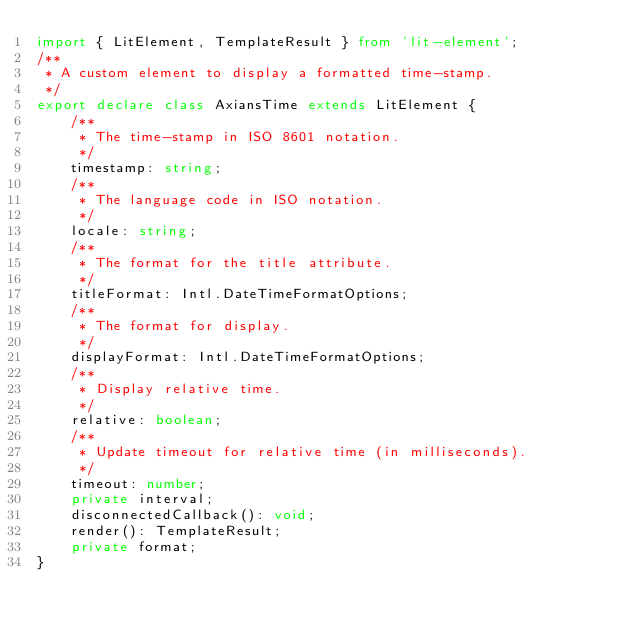Convert code to text. <code><loc_0><loc_0><loc_500><loc_500><_TypeScript_>import { LitElement, TemplateResult } from 'lit-element';
/**
 * A custom element to display a formatted time-stamp.
 */
export declare class AxiansTime extends LitElement {
    /**
     * The time-stamp in ISO 8601 notation.
     */
    timestamp: string;
    /**
     * The language code in ISO notation.
     */
    locale: string;
    /**
     * The format for the title attribute.
     */
    titleFormat: Intl.DateTimeFormatOptions;
    /**
     * The format for display.
     */
    displayFormat: Intl.DateTimeFormatOptions;
    /**
     * Display relative time.
     */
    relative: boolean;
    /**
     * Update timeout for relative time (in milliseconds).
     */
    timeout: number;
    private interval;
    disconnectedCallback(): void;
    render(): TemplateResult;
    private format;
}
</code> 